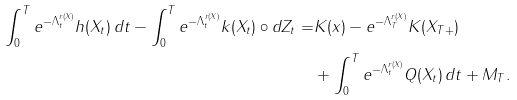<formula> <loc_0><loc_0><loc_500><loc_500>\int _ { 0 } ^ { T } e ^ { - \Lambda _ { t } ^ { r ( X ) } } h ( X _ { t } ) \, d t - \int _ { 0 } ^ { T } e ^ { - \Lambda _ { t } ^ { r ( X ) } } k ( X _ { t } ) \circ d Z _ { t } = & K ( x ) - e ^ { - \Lambda _ { T } ^ { r ( X ) } } K ( X _ { T + } ) \\ & + \int _ { 0 } ^ { T } e ^ { - \Lambda _ { t } ^ { r ( X ) } } Q ( X _ { t } ) \, d t + M _ { T } .</formula> 